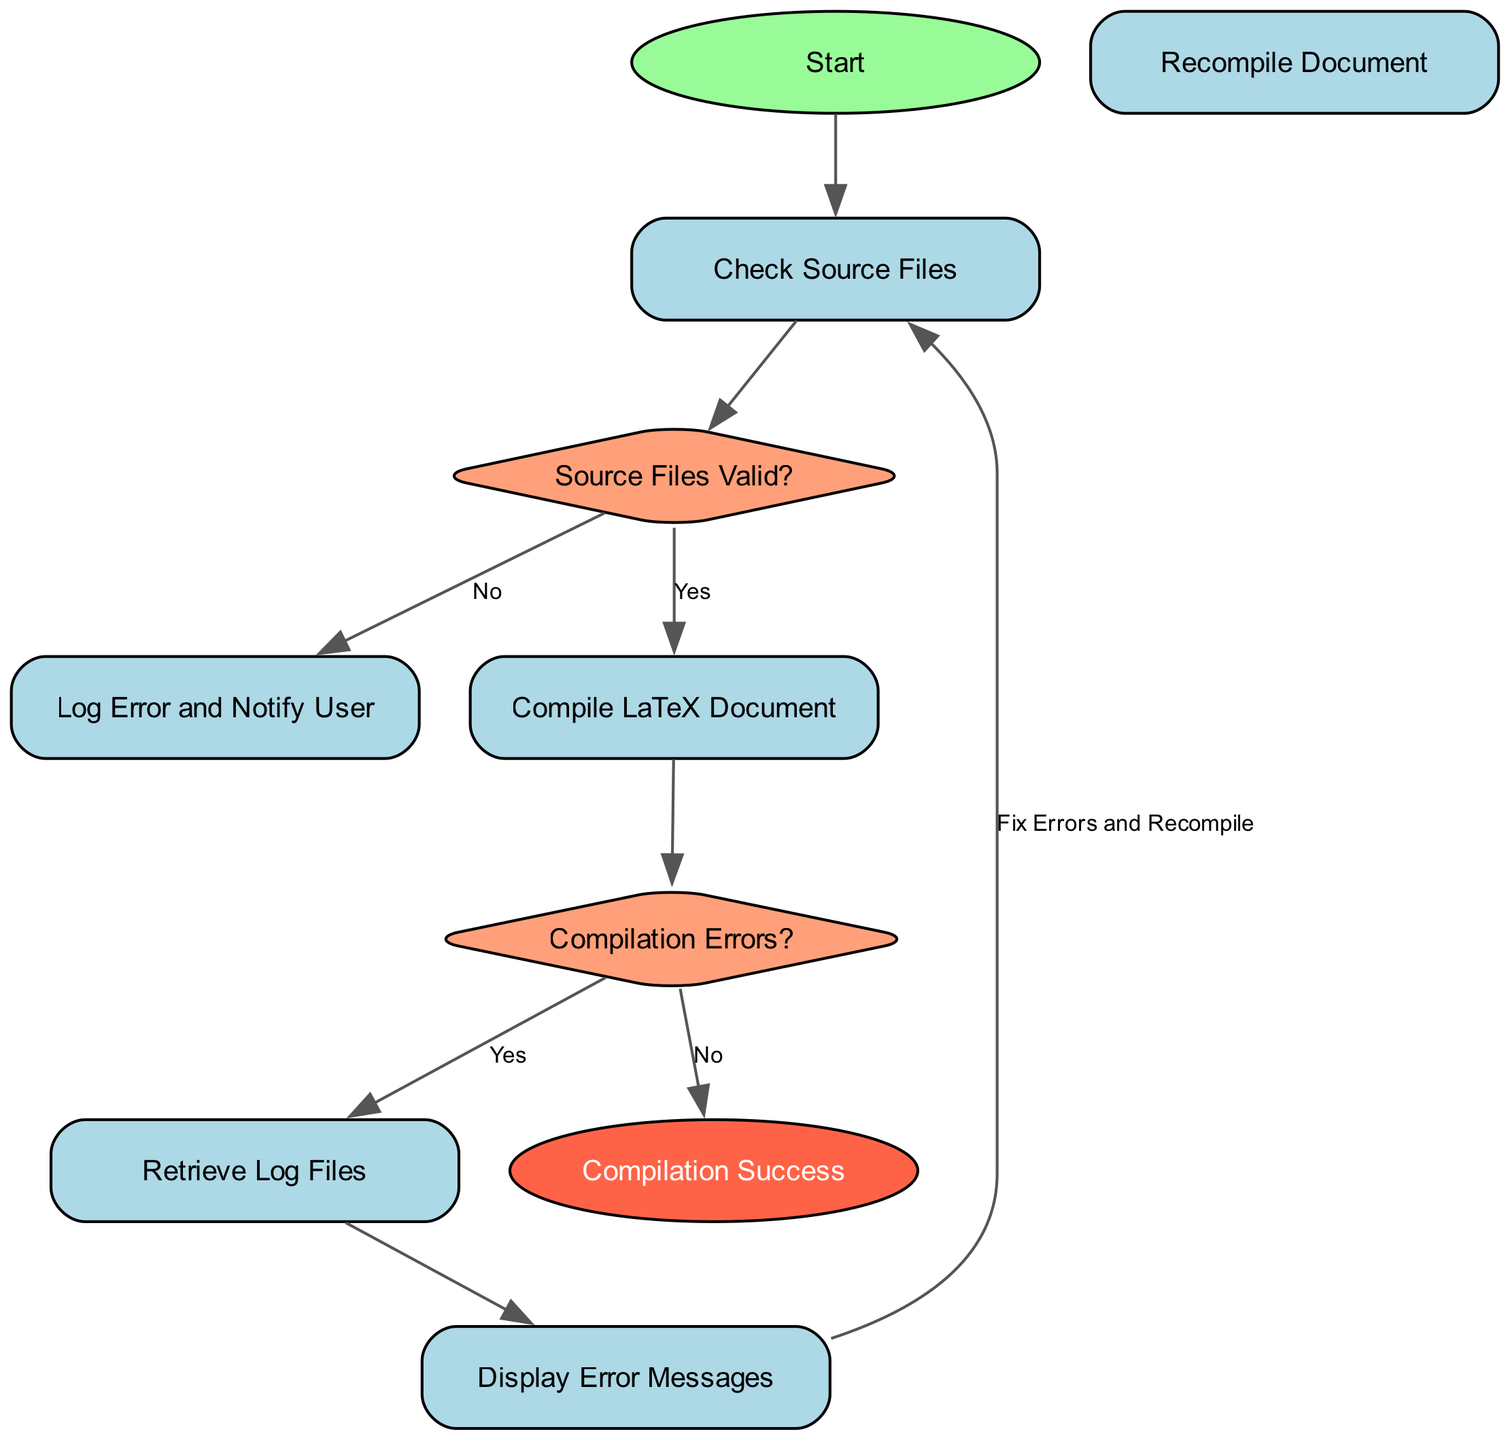What is the first step in the flowchart? The first step in the flowchart is labeled "Start". This is typically the entry point of the process outlined within the diagram.
Answer: Start How many decision nodes are present in the flowchart? There are two decision nodes in the flowchart: "Source Files Valid?" and "Compilation Errors?". Each decision node is identified by its diamond shape.
Answer: 2 What happens if the source files are not valid? If the source files are not valid, the flowchart directs to "Log Error and Notify User". This is indicated by the arrow labeled "No" leading to this process.
Answer: Log Error and Notify User What is the final outcome of a successful compilation? The final outcome of a successful compilation is labeled "Compilation Success". This is indicated by the end node, marking the process's completion.
Answer: Compilation Success If there are compilation errors, what is the next step? If there are compilation errors, the next step is to "Retrieve Log Files", as indicated by the arrow labeled "Yes" from the decision node "Compilation Errors?".
Answer: Retrieve Log Files What action follows displaying error messages? After displaying error messages, the flowchart instructs to "Fix Errors and Recompile". This shows the feedback loop to address errors.
Answer: Fix Errors and Recompile Which node is directly connected to "Compile LaTeX Document"? The node directly connected to "Compile LaTeX Document" is the decision node "Compilation Errors?", represented by an arrow following the compilation process.
Answer: Compilation Errors? What type of flowchart is represented here? This is a programming flowchart specifically designed for automated LaTeX document compilation and error handling. It outlines decision-making and processes involved.
Answer: Programming flowchart What does the flowchart suggest when no compilation errors are found? When no compilation errors are found, the flowchart directs to "Compilation Success", indicating successful completion of the compilation process.
Answer: Compilation Success 